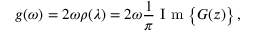Convert formula to latex. <formula><loc_0><loc_0><loc_500><loc_500>g ( \omega ) = 2 \omega \rho ( \lambda ) = 2 \omega \frac { 1 } { \pi } I m \left \{ G ( z ) \right \} \, ,</formula> 